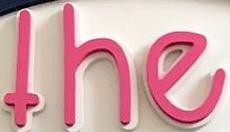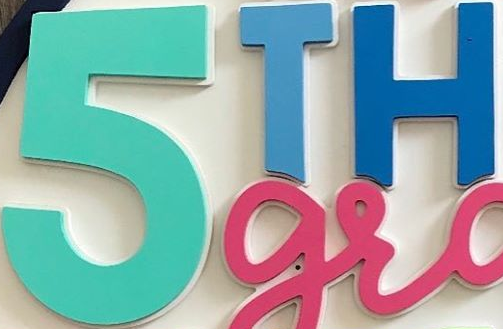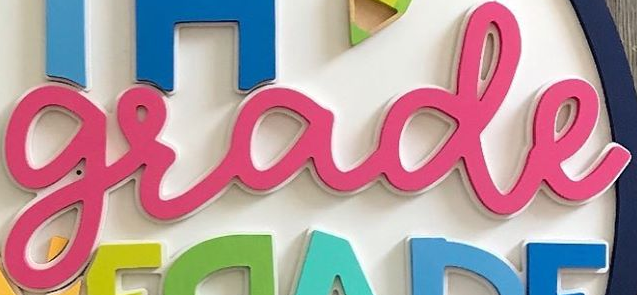What words are shown in these images in order, separated by a semicolon? the; 5TH; grade 